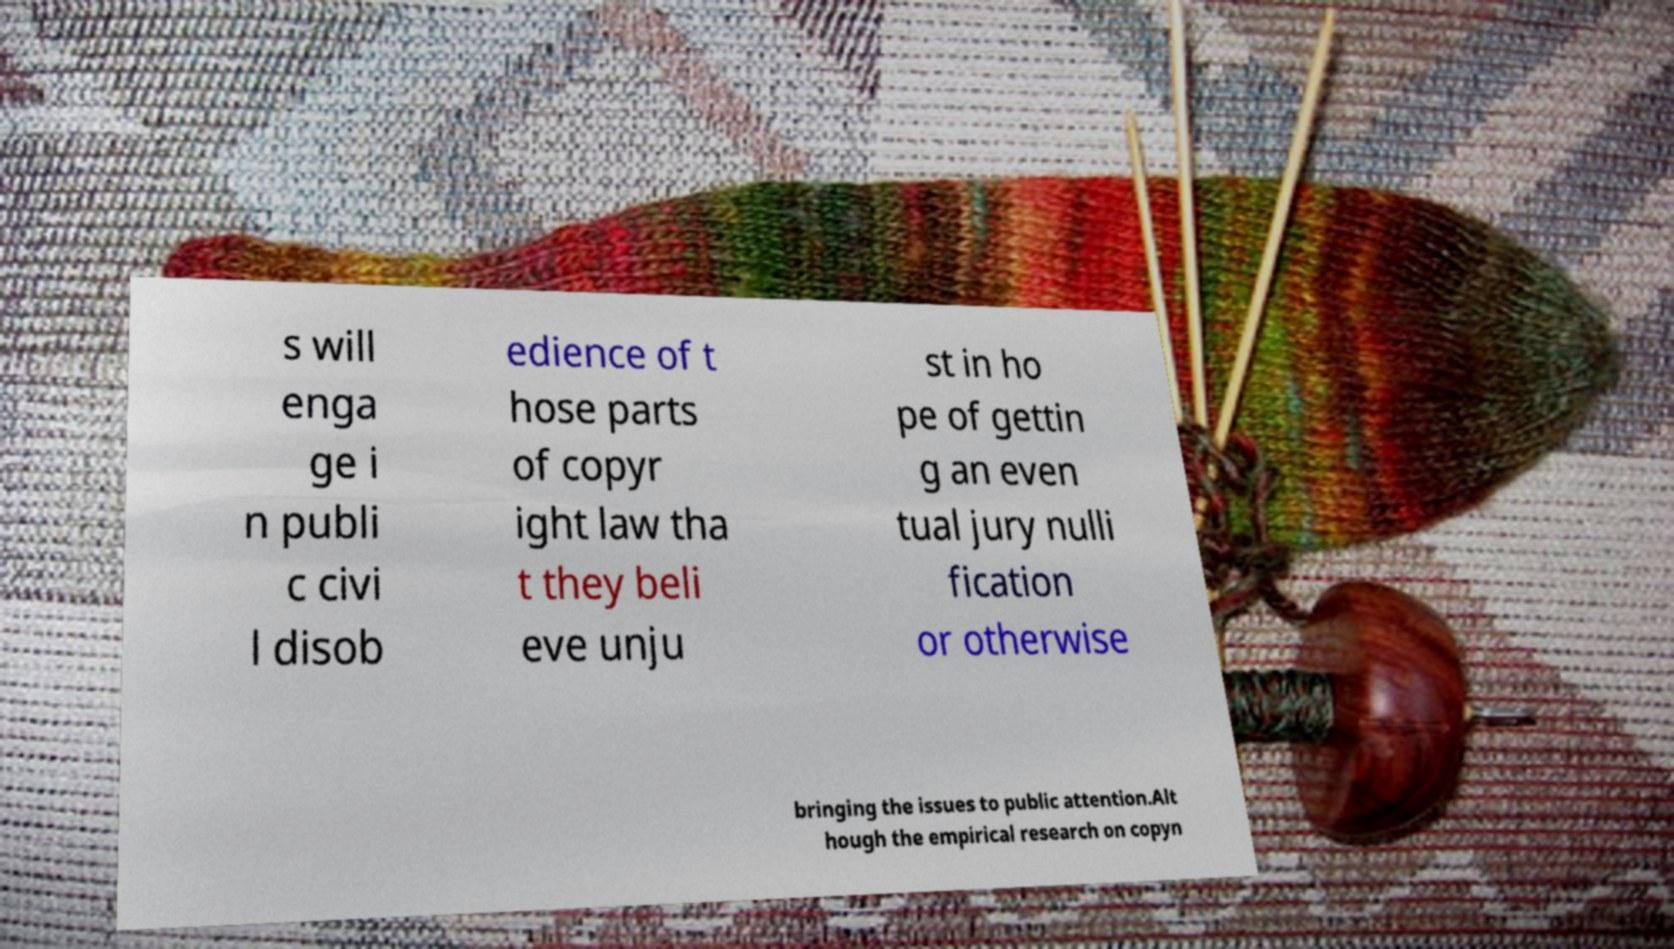What messages or text are displayed in this image? I need them in a readable, typed format. s will enga ge i n publi c civi l disob edience of t hose parts of copyr ight law tha t they beli eve unju st in ho pe of gettin g an even tual jury nulli fication or otherwise bringing the issues to public attention.Alt hough the empirical research on copyn 